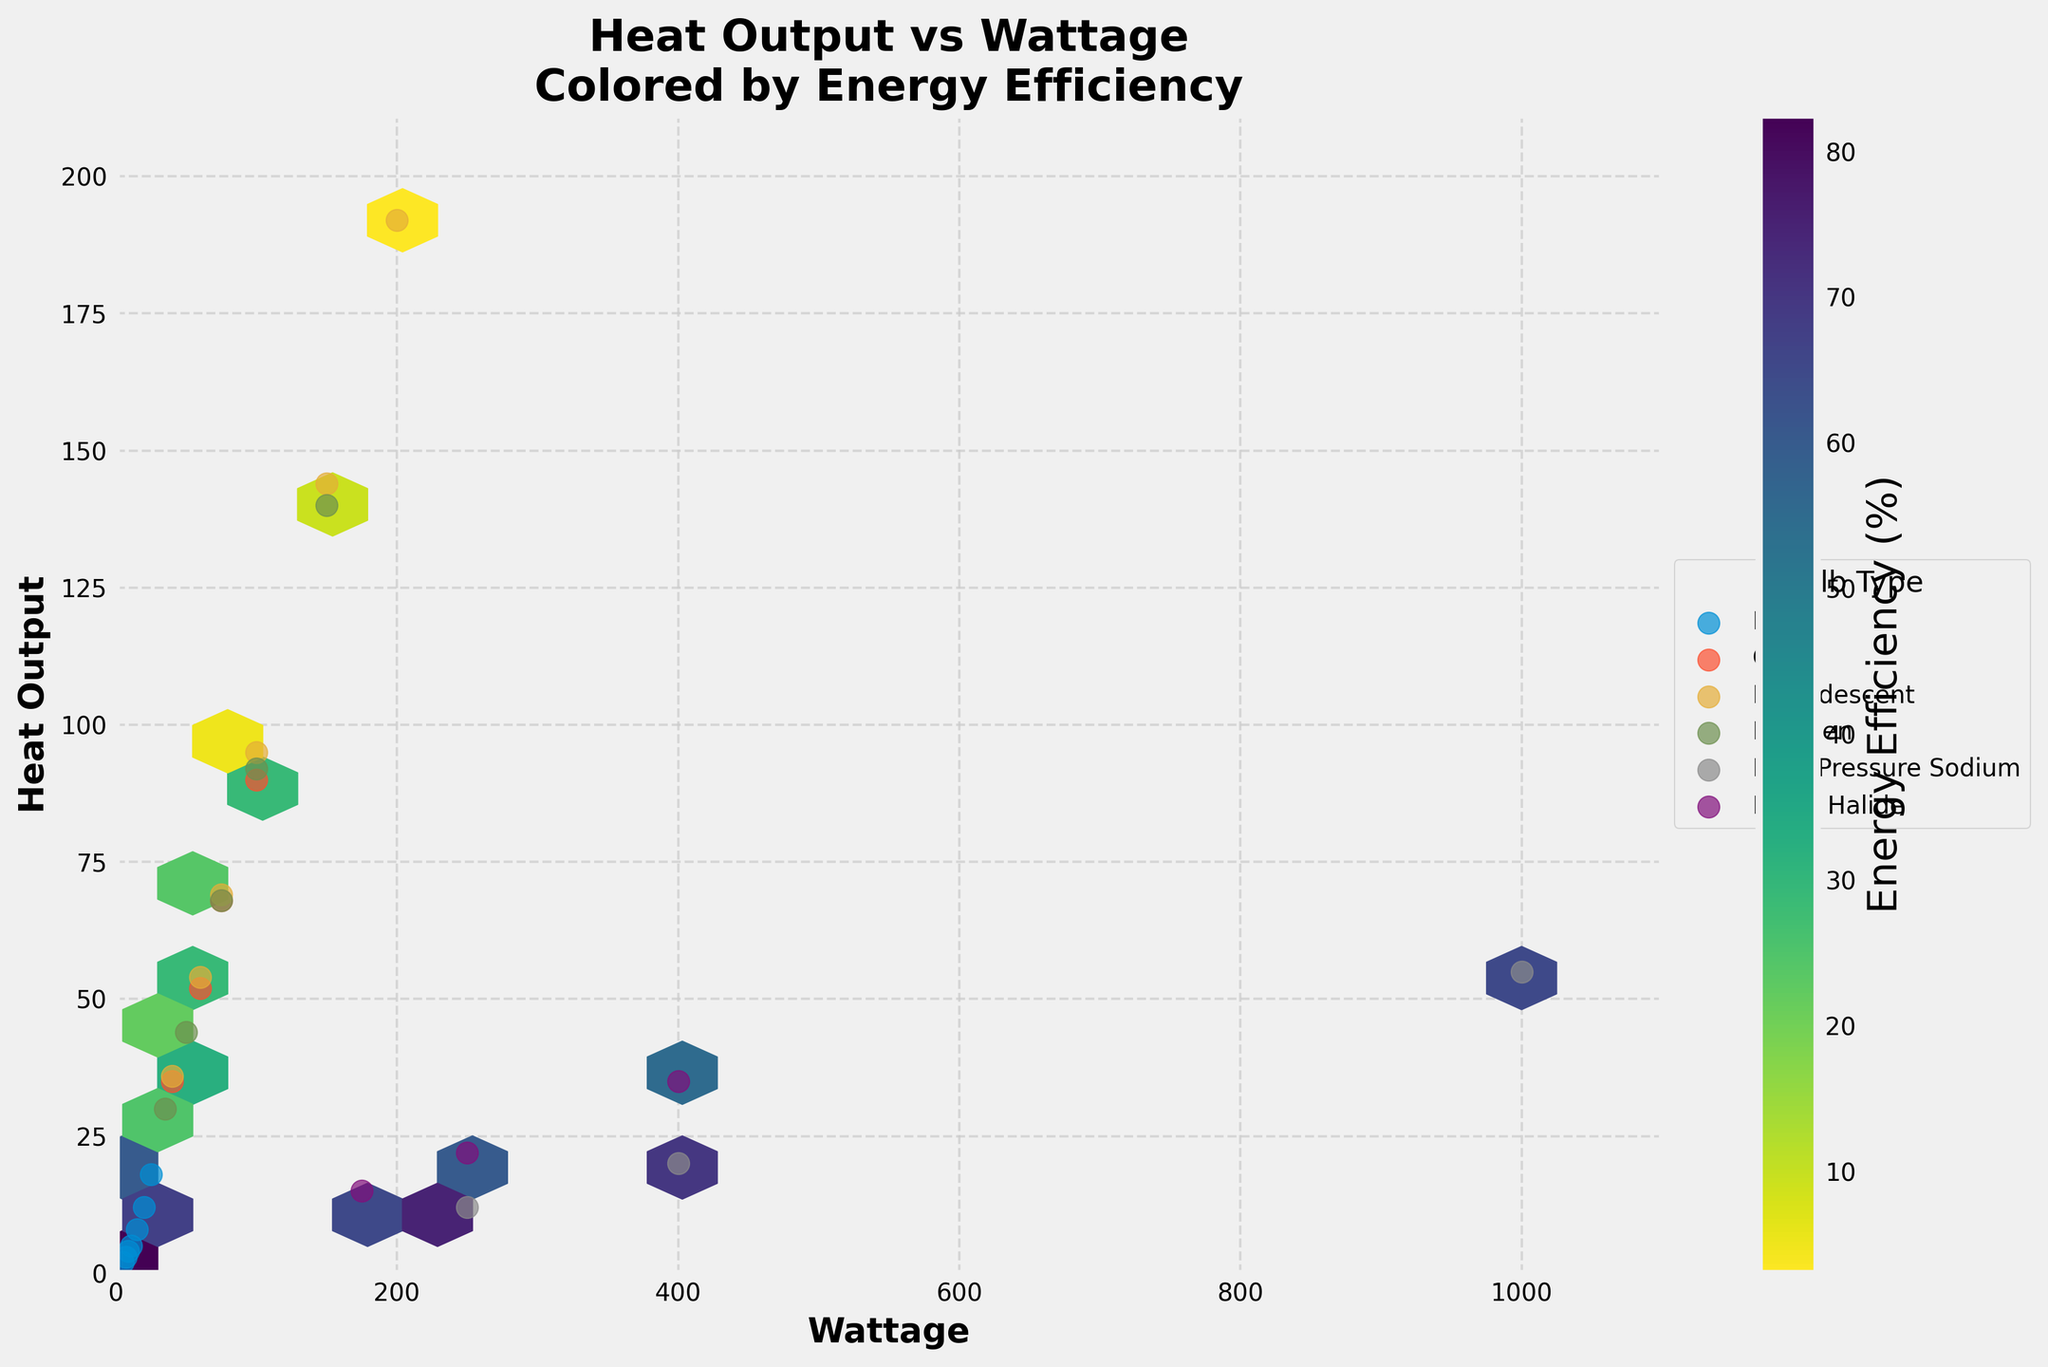What is the title of the hexbin plot? The title is located at the top center of the plot, indicating the relationship between heat output and wattage, colored by energy efficiency. This is helpful for understanding the overall purpose of the plot.
Answer: Heat Output vs Wattage Colored by Energy Efficiency What does the color represent in the hexbin plot? The color gradient of the hexagons represents the energy efficiency values, with the color scale shown on the color bar to the right of the plot.
Answer: Energy Efficiency Which bulb type appears to have the highest wattage in the plot? By looking at the scatter overlays on top of the hexbin plot, we identify which bulb type extends to the highest wattage value on the x-axis.
Answer: High-Pressure Sodium In terms of heat output, which bulb type shows the highest value for a wattage of 100W? By locating the clusters around 100W on the x-axis, we examine the y-axis values and identify which bulb type has the highest heat output at this wattage.
Answer: Incandescent Which bulb type is the most energy efficient for low wattages (around 5W to 25W)? By examining the lower end of the x-axis (5W to 25W) and referring to the color bar indicating energy efficiency, we can determine the bulb type with higher efficiency based on the color gradient.
Answer: LED How does the heat output of CFL bulbs around 40W compare to Halogen bulbs of the same wattage? By comparing the y-axis values for heat output around 40W for both CFL and Halogen bulb types, we can see which bulb type has a higher heat output.
Answer: Higher for CFL Comparing LED and Incandescent bulbs, which has better energy efficiency across their respective wattage ranges? By cross-referencing the color gradient associated with energy efficiency for both bulb types across their wattage ranges, we can determine which bulb type shows better energy efficiency overall.
Answer: LED What is the relationship between heat output and wattage for Metal Halide bulbs? By analyzing the scatter points for Metal Halide bulbs, observe the trend between heat output on the y-axis and wattage on the x-axis.
Answer: Generally, as wattage increases, heat output increases Is there an overlap in the energy efficiency range for CFL and Halogen bulbs at any wattage? By comparing the color gradient of hexagons for the overlapping wattage range of CFL and Halogen bulbs, determine if there are any shared shades indicating similar efficiency levels.
Answer: Yes Based on the plot, which bulb type would you recommend for energy efficiency considering both low and high wattage ranges? Evaluate the color gradient of the hexagons representing energy efficiency for different bulb types across their wattage ranges to determine which type remains most efficient.
Answer: LED 